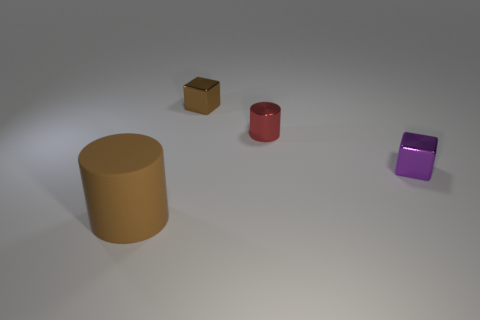Is there anything else that is the same size as the rubber thing?
Provide a short and direct response. No. Is there any other thing that is the same material as the large brown cylinder?
Provide a succinct answer. No. The tiny cylinder has what color?
Ensure brevity in your answer.  Red. How many small shiny blocks have the same color as the tiny metal cylinder?
Provide a succinct answer. 0. What is the material of the red thing that is the same size as the purple metal thing?
Your answer should be compact. Metal. Is there a small brown metal thing that is to the left of the cylinder that is in front of the shiny cylinder?
Your answer should be very brief. No. What number of other things are there of the same color as the small cylinder?
Offer a terse response. 0. What is the size of the brown shiny cube?
Keep it short and to the point. Small. Are there any brown objects?
Provide a succinct answer. Yes. Is the number of tiny purple things behind the red cylinder greater than the number of small red cylinders on the right side of the brown matte cylinder?
Provide a succinct answer. No. 